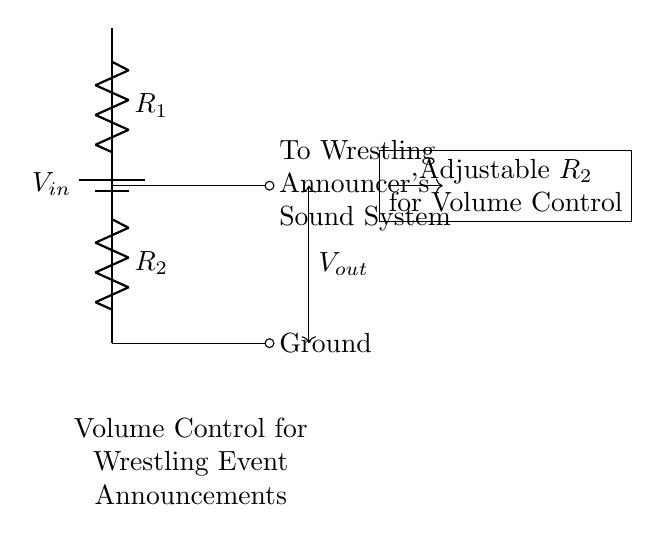What is the input voltage in the circuit? The input voltage is labeled as \( V_{in} \) at the battery source at the top of the circuit diagram.
Answer: \( V_{in} \) What do the resistors in the circuit represent? The resistors \( R_1 \) and \( R_2 \) are used to create a voltage divider. Each resistor has a specific value that influences the output voltage depending on their ratio.
Answer: \( R_1 \) and \( R_2 \) What is the purpose of adjustable \( R_2 \)? Adjustable \( R_2 \) allows for variation in resistance, which in turn enables control over the output voltage \( V_{out} \), thus controlling the volume in the sound system.
Answer: Volume control How does the voltage output relate to the resistor values? The output voltage \( V_{out} \) is determined by the formula \( V_{out} = V_{in} \cdot \frac{R_2}{R_1 + R_2} \), showing that output depends on both resistors’ values.
Answer: Voltage divider formula What is the output connection in the circuit? The output connection directly leads to the wrestling announcer's sound system, as indicated by the label on the right side of \( V_{out} \).
Answer: Announcer's sound system 